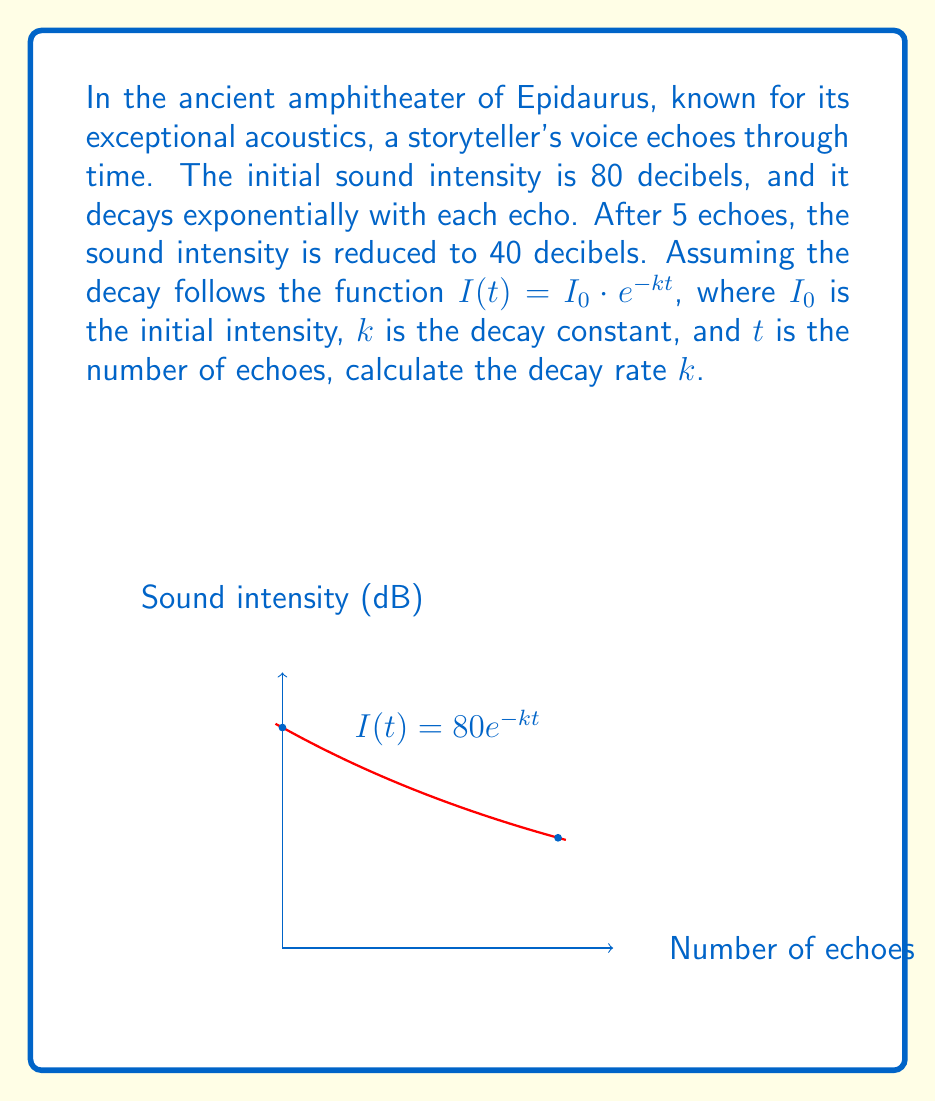Show me your answer to this math problem. Let's approach this step-by-step:

1) We're given the exponential decay function: $I(t) = I_0 \cdot e^{-kt}$

2) We know:
   - Initial intensity $I_0 = 80$ decibels
   - After 5 echoes $(t=5)$, the intensity $I(5) = 40$ decibels

3) Let's plug these values into our equation:
   $40 = 80 \cdot e^{-k(5)}$

4) Divide both sides by 80:
   $\frac{1}{2} = e^{-5k}$

5) Take the natural logarithm of both sides:
   $\ln(\frac{1}{2}) = \ln(e^{-5k})$

6) Simplify the right side using logarithm properties:
   $\ln(\frac{1}{2}) = -5k$

7) Solve for $k$:
   $k = -\frac{1}{5}\ln(\frac{1}{2})$

8) Simplify:
   $k = \frac{\ln(2)}{5} \approx 0.138629$

Therefore, the decay rate $k$ is approximately 0.138629 per echo.
Answer: $k = \frac{\ln(2)}{5} \approx 0.138629$ 